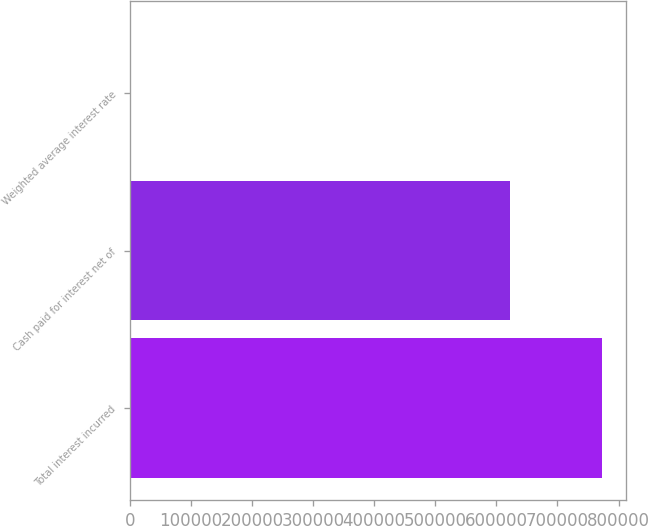Convert chart to OTSL. <chart><loc_0><loc_0><loc_500><loc_500><bar_chart><fcel>Total interest incurred<fcel>Cash paid for interest net of<fcel>Weighted average interest rate<nl><fcel>773662<fcel>622297<fcel>6<nl></chart> 